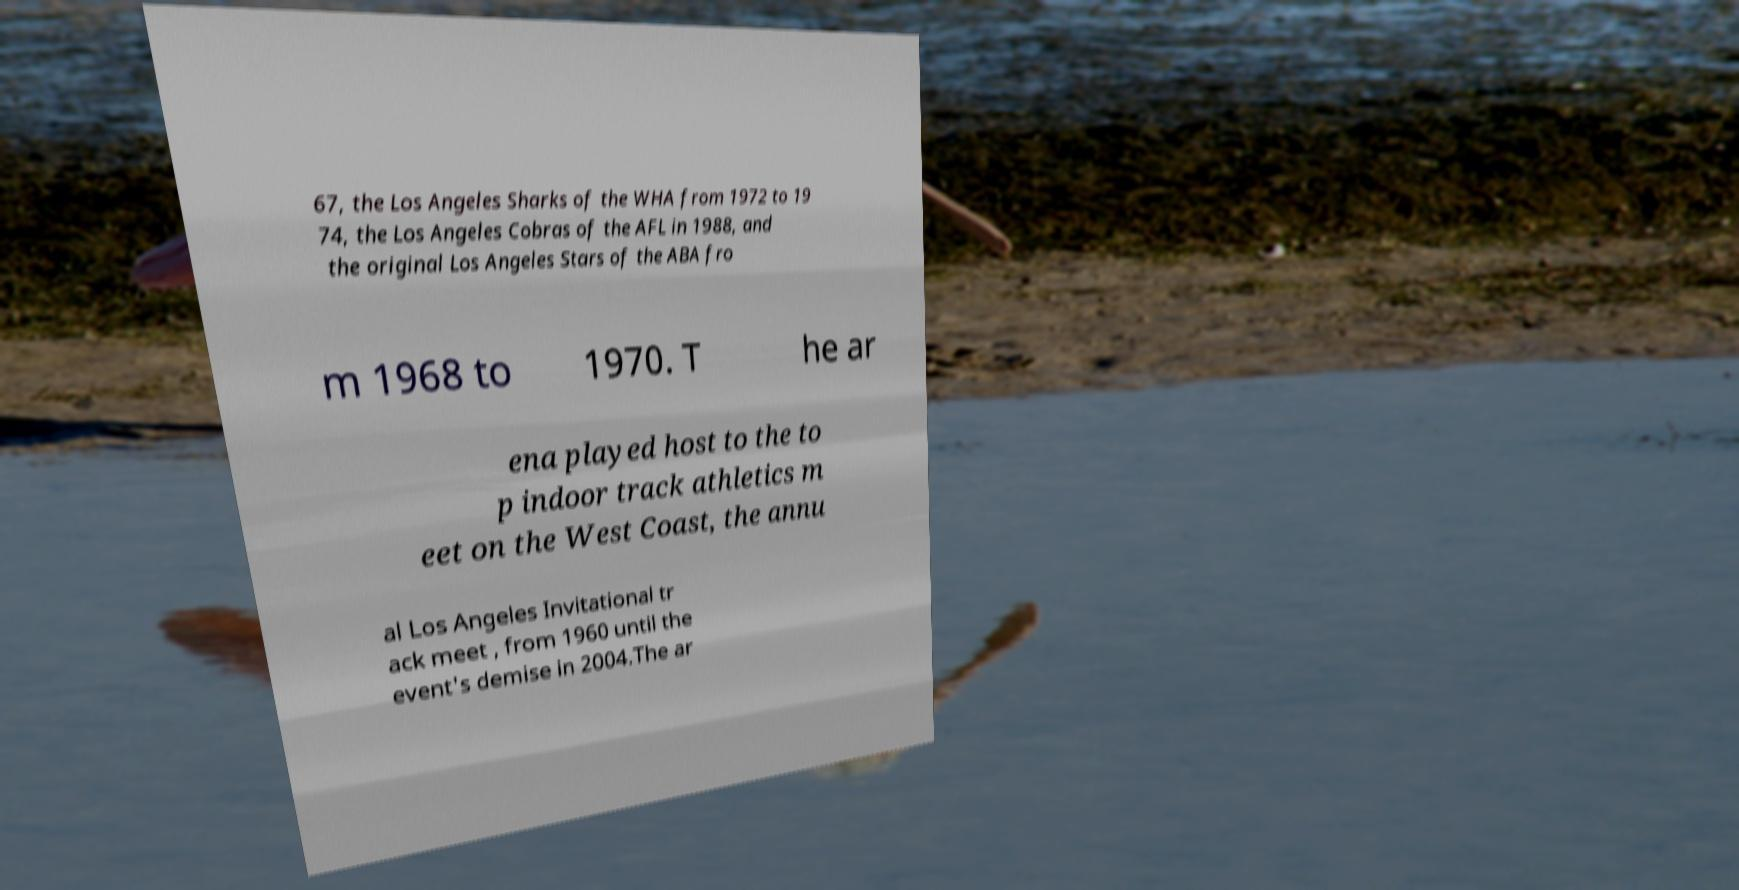For documentation purposes, I need the text within this image transcribed. Could you provide that? 67, the Los Angeles Sharks of the WHA from 1972 to 19 74, the Los Angeles Cobras of the AFL in 1988, and the original Los Angeles Stars of the ABA fro m 1968 to 1970. T he ar ena played host to the to p indoor track athletics m eet on the West Coast, the annu al Los Angeles Invitational tr ack meet , from 1960 until the event's demise in 2004.The ar 